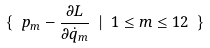<formula> <loc_0><loc_0><loc_500><loc_500>\{ \ p _ { m } - \frac { \partial L } { \partial \dot { q } _ { m } } \ | \ 1 \leq m \leq 1 2 \ \}</formula> 